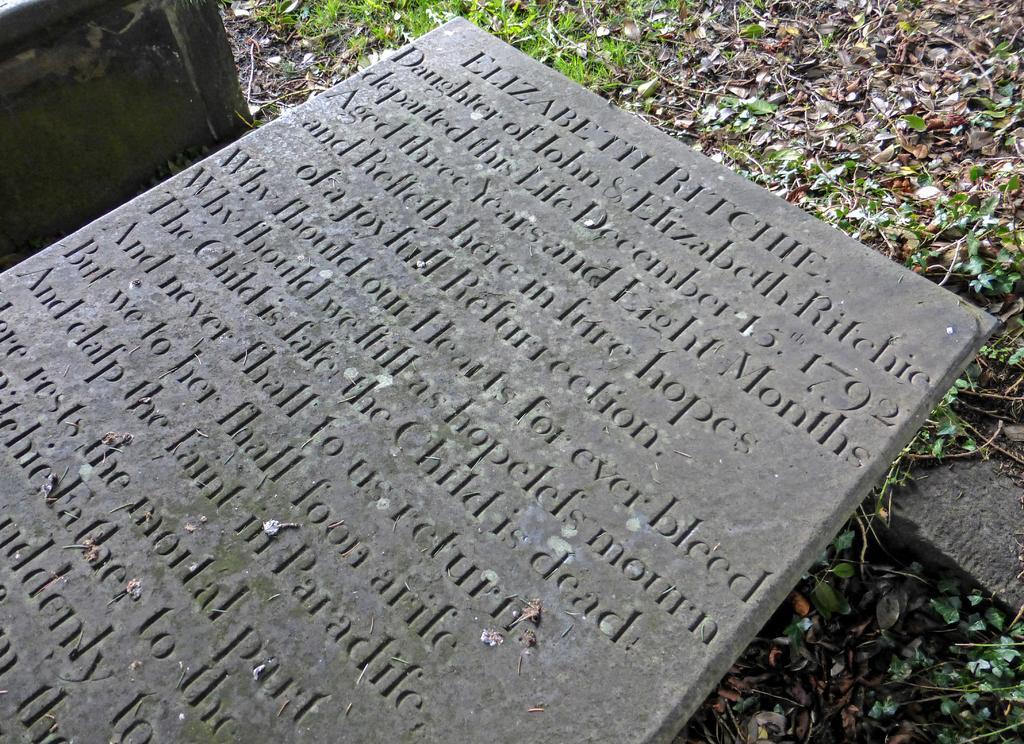How would you summarize this image in a sentence or two? In this image I can see the concrete block and few words written on the concrete block. I can see few leaves on the ground and some grass which is green in color. 